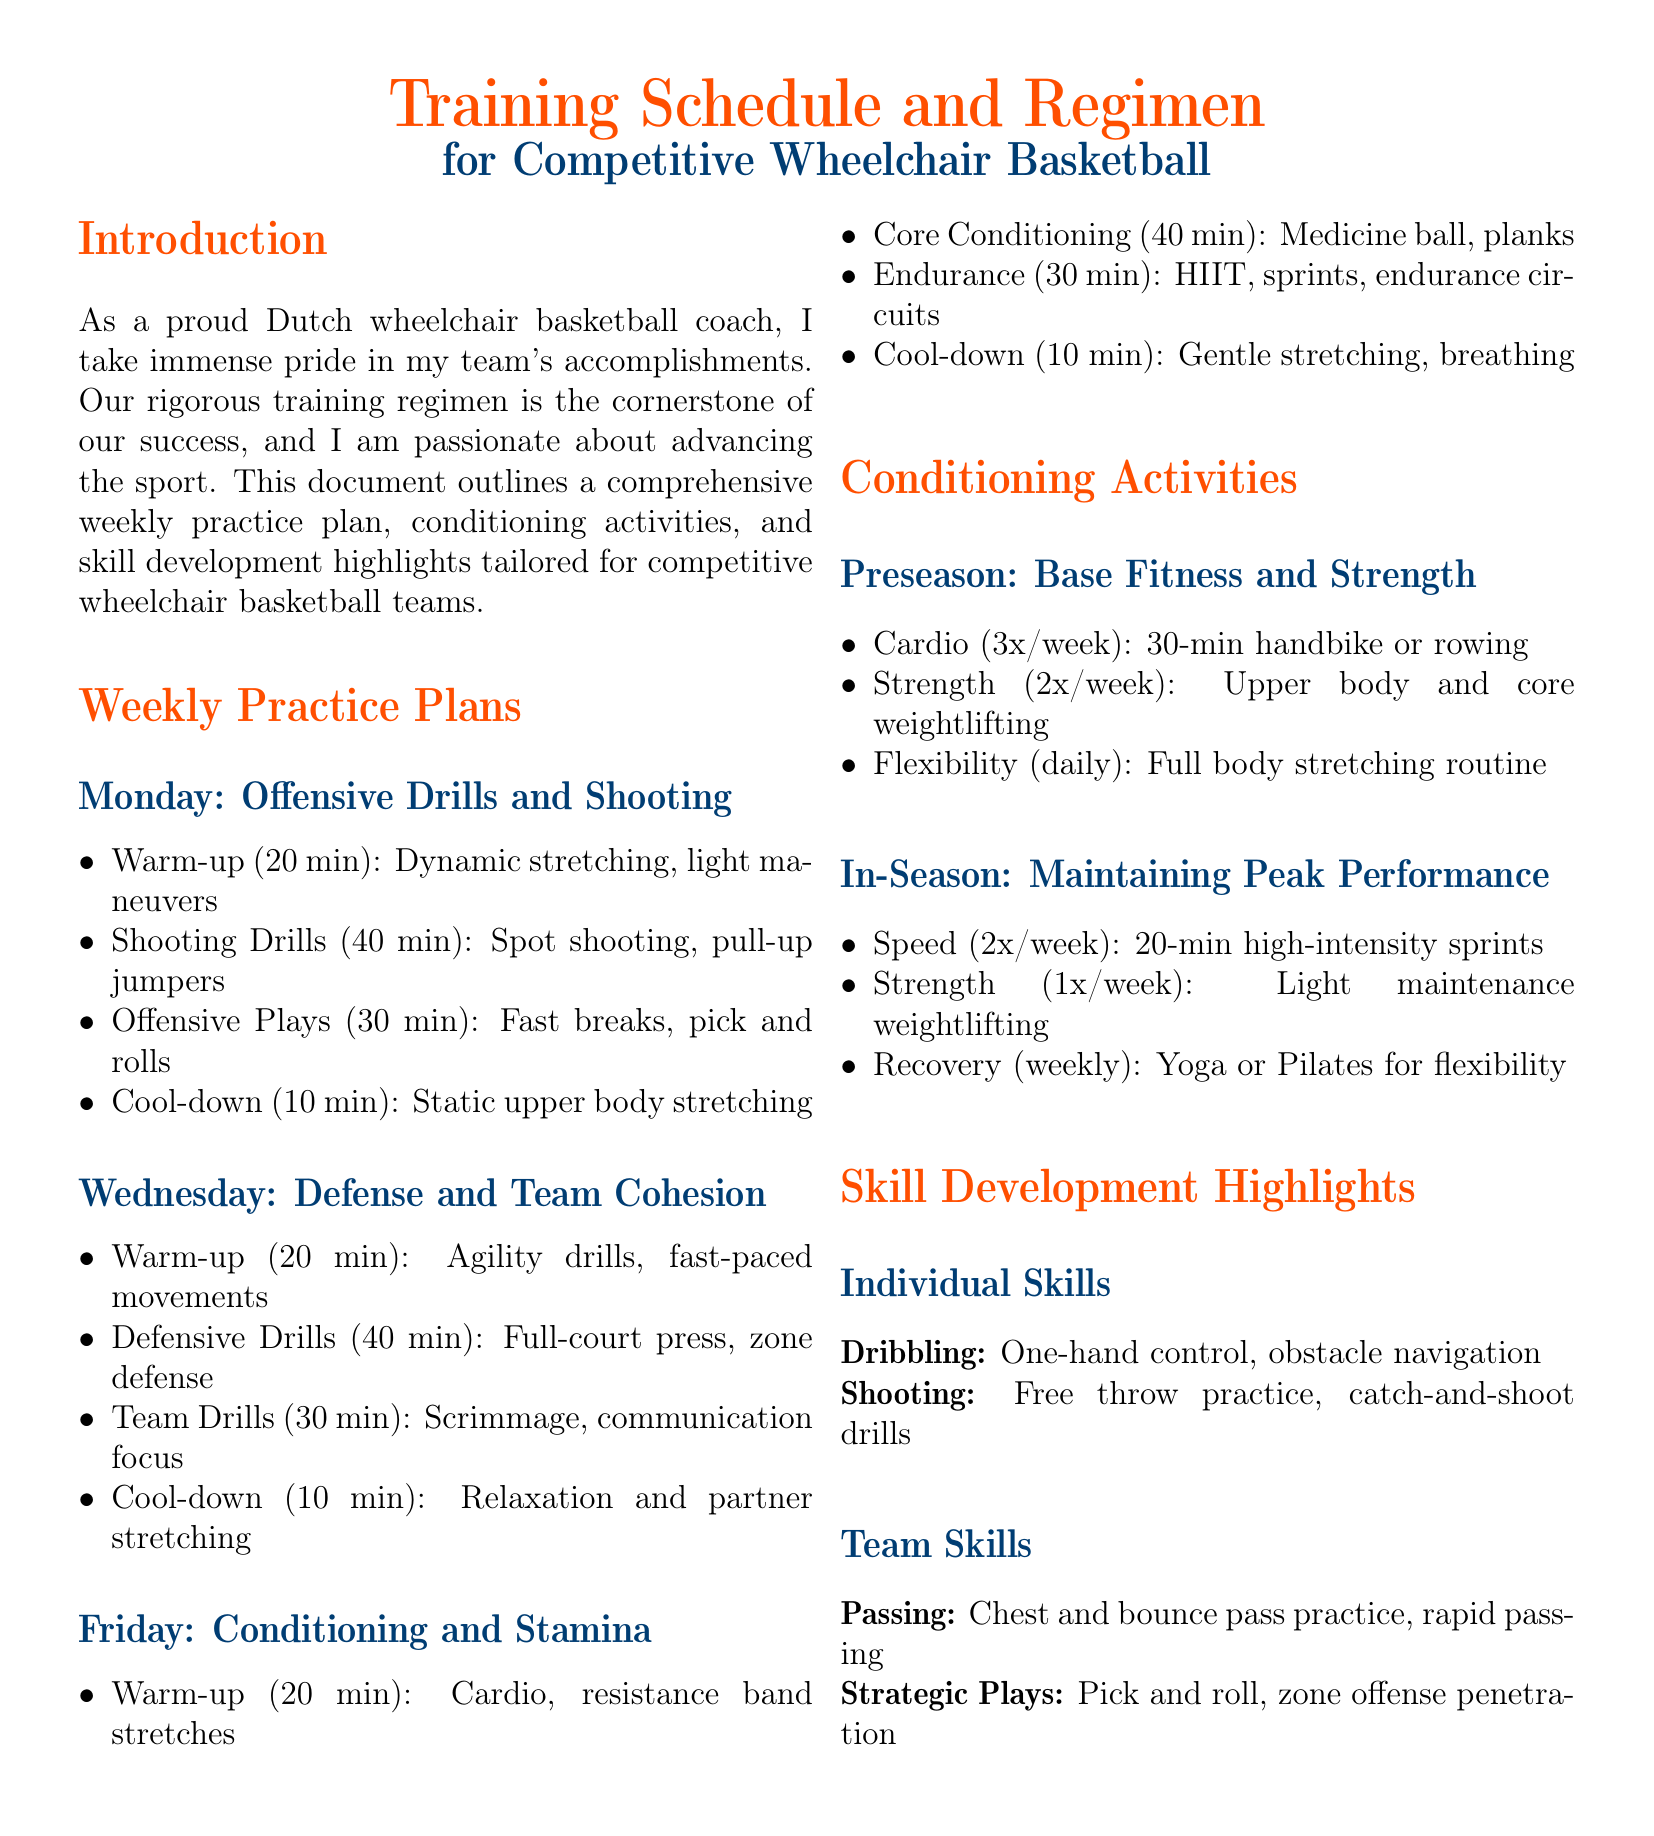What is the duration of the warm-up on Monday? The warm-up on Monday lasts for 20 minutes as stated in the practice plan.
Answer: 20 min How many minutes are dedicated to shooting drills on Monday? The shooting drills on Monday are allocated 40 minutes according to the weekly practice plan.
Answer: 40 min What type of conditioning activity is performed 3 times a week in preseason? The conditioning activity performed three times a week during the preseason is cardio, as mentioned in the document.
Answer: Cardio On which day are offensive drills emphasized? The practice plan focuses on offensive drills on Monday, as detailed in the weekly schedule.
Answer: Monday What is highlighted under individual skills? Under individual skills, dribbling and shooting are specifically highlighted as per the skill development section.
Answer: Dribbling, Shooting Which defensive drill is included in the Wednesday practice? The full-court press is listed as a defensive drill for Wednesday's practice session.
Answer: Full-court press How often is strength training conducted during the in-season? The document states that strength training is conducted once a week during the in-season.
Answer: 1x/week What is the focus of warm-up on Friday? The warm-up on Friday focuses on cardio and resistance band stretches as described in the practice plan.
Answer: Cardio, resistance band stretches What is the primary goal of the document? The document aims to outline a comprehensive training regimen for competitive wheelchair basketball teams.
Answer: Training regimen 